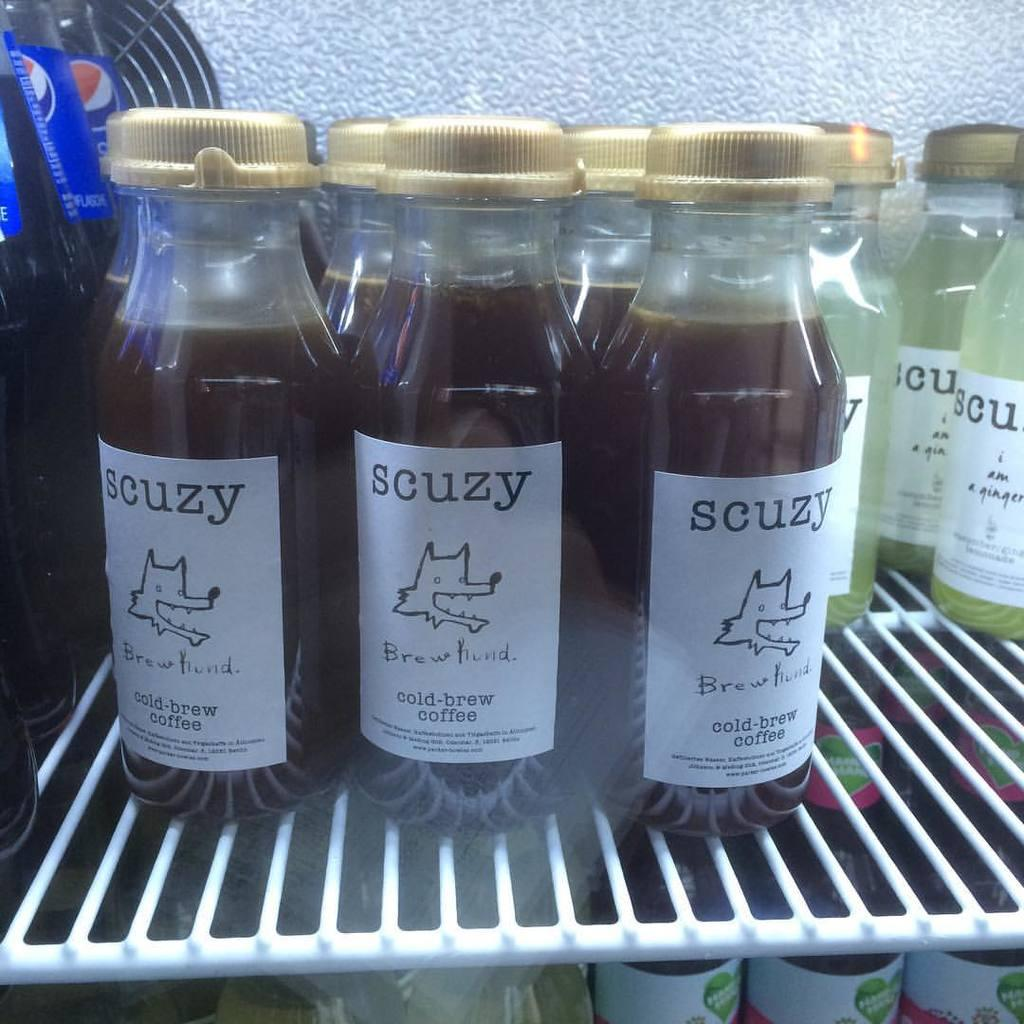<image>
Summarize the visual content of the image. Bottles of scuzy cold-brew coffee are seen in a beverage cooler. 